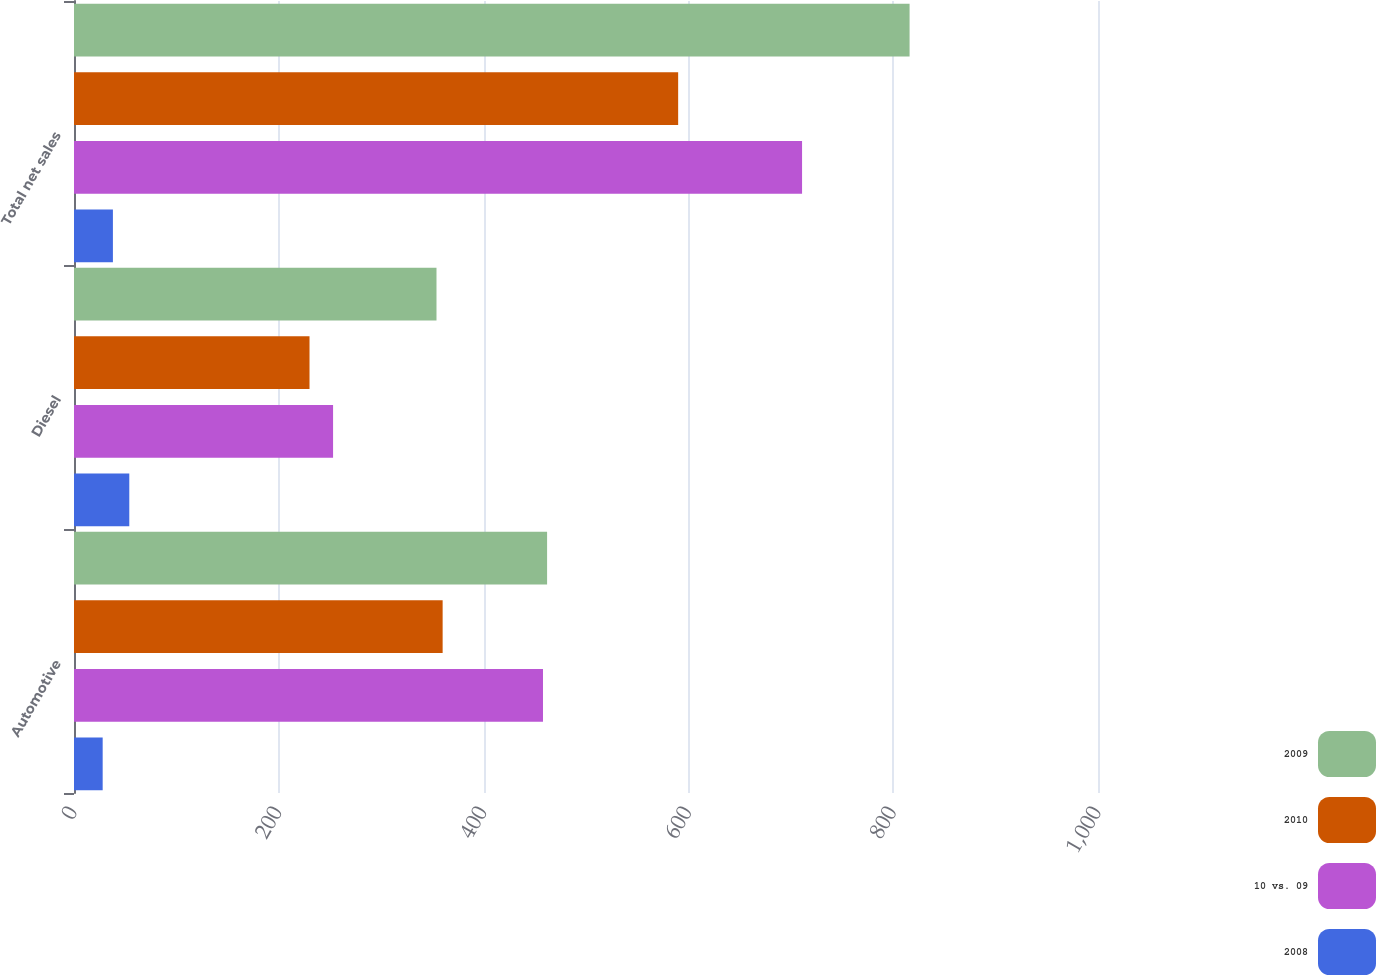Convert chart to OTSL. <chart><loc_0><loc_0><loc_500><loc_500><stacked_bar_chart><ecel><fcel>Automotive<fcel>Diesel<fcel>Total net sales<nl><fcel>2009<fcel>462<fcel>354<fcel>816<nl><fcel>2010<fcel>360<fcel>230<fcel>590<nl><fcel>10 vs. 09<fcel>458<fcel>253<fcel>711<nl><fcel>2008<fcel>28<fcel>54<fcel>38<nl></chart> 